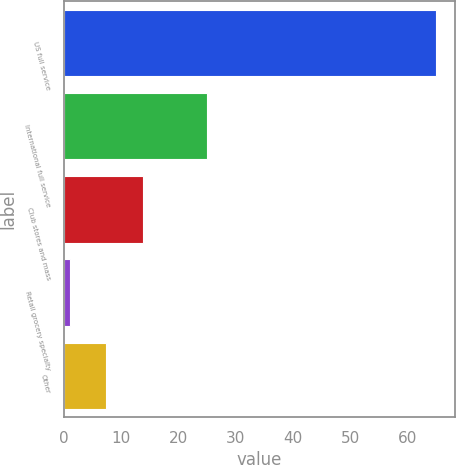Convert chart. <chart><loc_0><loc_0><loc_500><loc_500><bar_chart><fcel>US full service<fcel>International full service<fcel>Club stores and mass<fcel>Retail grocery specialty<fcel>Other<nl><fcel>65<fcel>25<fcel>13.8<fcel>1<fcel>7.4<nl></chart> 